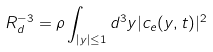<formula> <loc_0><loc_0><loc_500><loc_500>R _ { d } ^ { - 3 } = \rho \int _ { \left | { y } \right | \leq 1 } d ^ { 3 } y | c _ { e } ( { y } , t ) | ^ { 2 }</formula> 